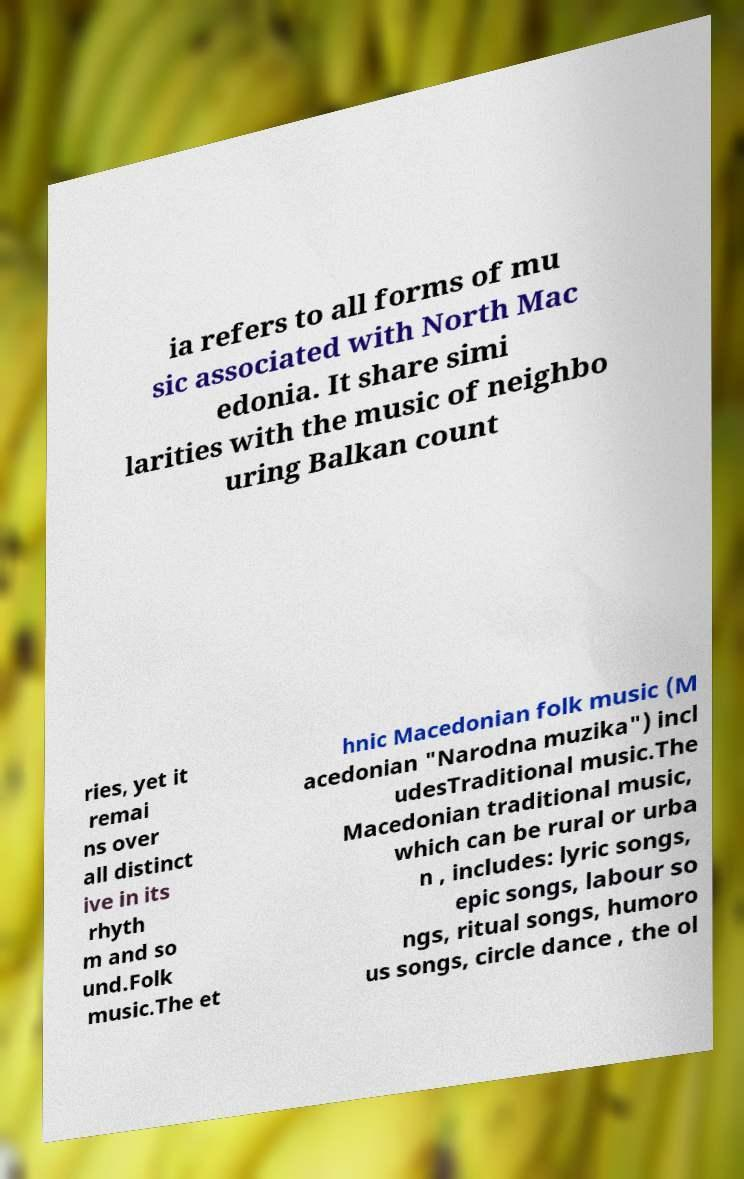I need the written content from this picture converted into text. Can you do that? ia refers to all forms of mu sic associated with North Mac edonia. It share simi larities with the music of neighbo uring Balkan count ries, yet it remai ns over all distinct ive in its rhyth m and so und.Folk music.The et hnic Macedonian folk music (M acedonian "Narodna muzika") incl udesTraditional music.The Macedonian traditional music, which can be rural or urba n , includes: lyric songs, epic songs, labour so ngs, ritual songs, humoro us songs, circle dance , the ol 